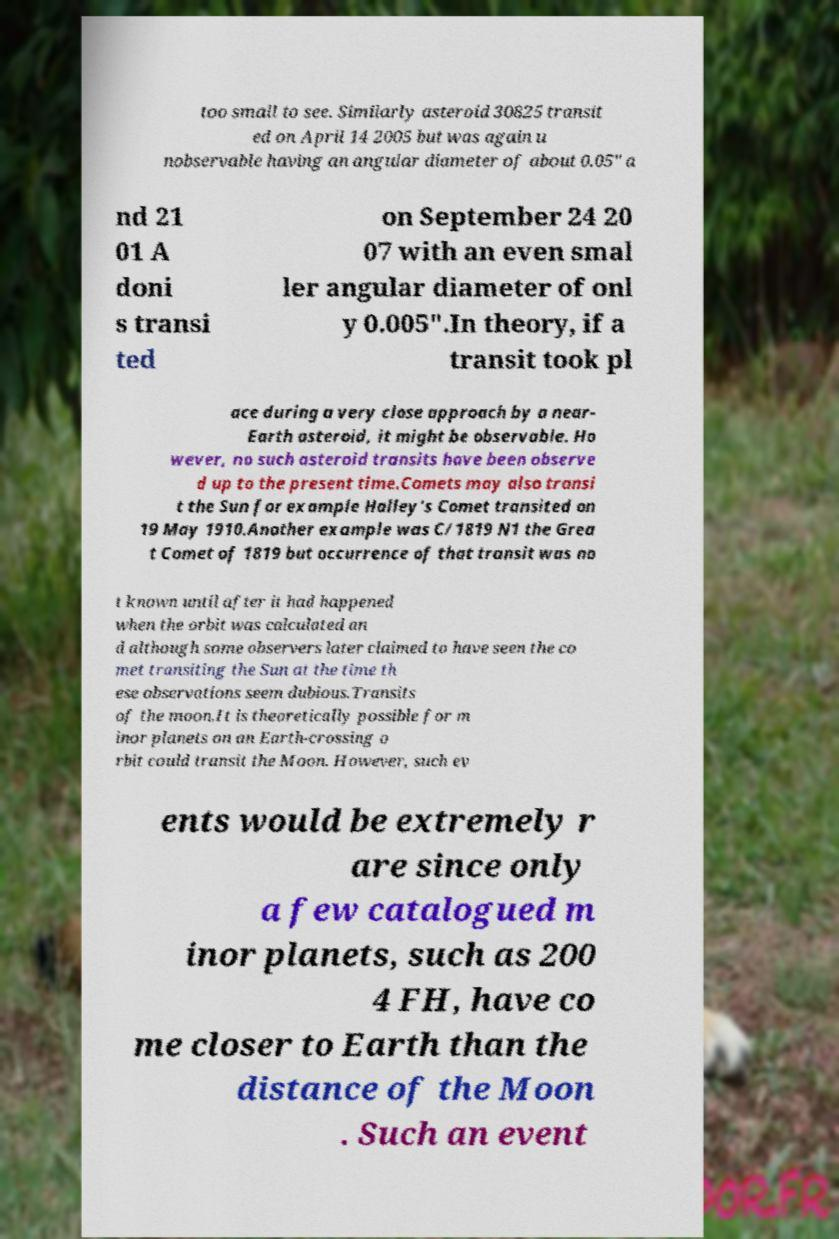Could you assist in decoding the text presented in this image and type it out clearly? too small to see. Similarly asteroid 30825 transit ed on April 14 2005 but was again u nobservable having an angular diameter of about 0.05″ a nd 21 01 A doni s transi ted on September 24 20 07 with an even smal ler angular diameter of onl y 0.005″.In theory, if a transit took pl ace during a very close approach by a near- Earth asteroid, it might be observable. Ho wever, no such asteroid transits have been observe d up to the present time.Comets may also transi t the Sun for example Halley's Comet transited on 19 May 1910.Another example was C/1819 N1 the Grea t Comet of 1819 but occurrence of that transit was no t known until after it had happened when the orbit was calculated an d although some observers later claimed to have seen the co met transiting the Sun at the time th ese observations seem dubious.Transits of the moon.It is theoretically possible for m inor planets on an Earth-crossing o rbit could transit the Moon. However, such ev ents would be extremely r are since only a few catalogued m inor planets, such as 200 4 FH, have co me closer to Earth than the distance of the Moon . Such an event 